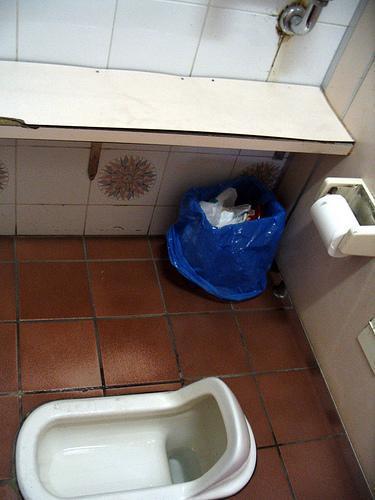How many rolls of toilet paper can be seen?
Give a very brief answer. 1. 